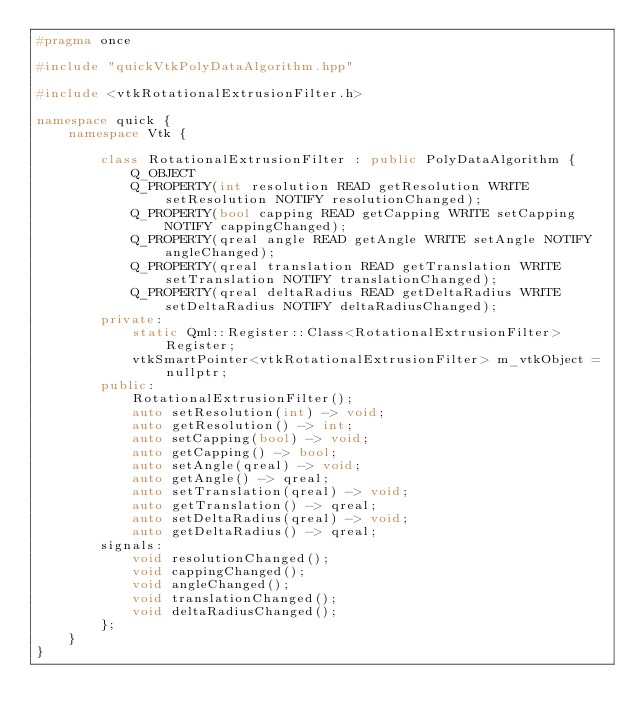Convert code to text. <code><loc_0><loc_0><loc_500><loc_500><_C++_>#pragma once

#include "quickVtkPolyDataAlgorithm.hpp"

#include <vtkRotationalExtrusionFilter.h>

namespace quick {
    namespace Vtk {

        class RotationalExtrusionFilter : public PolyDataAlgorithm {
            Q_OBJECT
            Q_PROPERTY(int resolution READ getResolution WRITE setResolution NOTIFY resolutionChanged);
            Q_PROPERTY(bool capping READ getCapping WRITE setCapping NOTIFY cappingChanged);
            Q_PROPERTY(qreal angle READ getAngle WRITE setAngle NOTIFY angleChanged);
            Q_PROPERTY(qreal translation READ getTranslation WRITE setTranslation NOTIFY translationChanged);
            Q_PROPERTY(qreal deltaRadius READ getDeltaRadius WRITE setDeltaRadius NOTIFY deltaRadiusChanged);
        private:
            static Qml::Register::Class<RotationalExtrusionFilter> Register;
            vtkSmartPointer<vtkRotationalExtrusionFilter> m_vtkObject = nullptr;
        public:
            RotationalExtrusionFilter();
            auto setResolution(int) -> void;
            auto getResolution() -> int;
            auto setCapping(bool) -> void;
            auto getCapping() -> bool;
            auto setAngle(qreal) -> void;
            auto getAngle() -> qreal;
            auto setTranslation(qreal) -> void;
            auto getTranslation() -> qreal;
            auto setDeltaRadius(qreal) -> void;
            auto getDeltaRadius() -> qreal;
        signals:
            void resolutionChanged();
            void cappingChanged();
            void angleChanged();
            void translationChanged();
            void deltaRadiusChanged();
        };
    }
}
</code> 